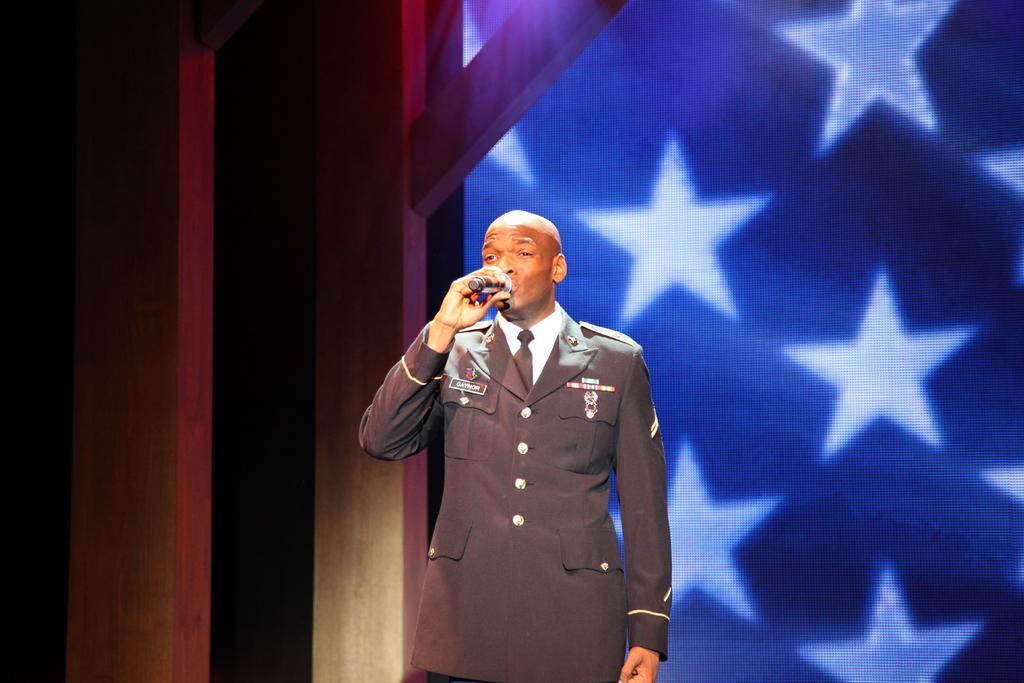In one or two sentences, can you explain what this image depicts? In the middle of the image we can see a man, he is holding a microphone, behind to him we can see a screen. 